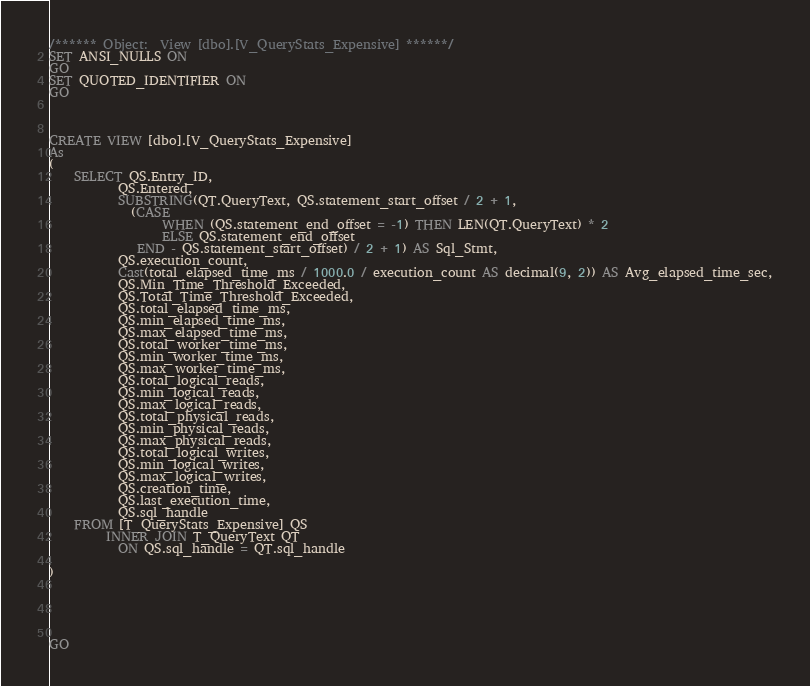Convert code to text. <code><loc_0><loc_0><loc_500><loc_500><_SQL_>/****** Object:  View [dbo].[V_QueryStats_Expensive] ******/
SET ANSI_NULLS ON
GO
SET QUOTED_IDENTIFIER ON
GO



CREATE VIEW [dbo].[V_QueryStats_Expensive] 
As 
(
	SELECT QS.Entry_ID,
           QS.Entered,
	       SUBSTRING(QT.QueryText, QS.statement_start_offset / 2 + 1, 
	         (CASE
	              WHEN (QS.statement_end_offset = -1) THEN LEN(QT.QueryText) * 2
	              ELSE QS.statement_end_offset
	          END - QS.statement_start_offset) / 2 + 1) AS Sql_Stmt,
	       QS.execution_count,
	       Cast(total_elapsed_time_ms / 1000.0 / execution_count AS decimal(9, 2)) AS Avg_elapsed_time_sec,
	       QS.Min_Time_Threshold_Exceeded,
	       QS.Total_Time_Threshold_Exceeded,
	       QS.total_elapsed_time_ms,
	       QS.min_elapsed_time_ms,
	       QS.max_elapsed_time_ms,
	       QS.total_worker_time_ms,
	       QS.min_worker_time_ms,
	       QS.max_worker_time_ms,
	       QS.total_logical_reads,
	       QS.min_logical_reads,
	       QS.max_logical_reads,
	       QS.total_physical_reads,
	       QS.min_physical_reads,
	       QS.max_physical_reads,
	       QS.total_logical_writes,
	       QS.min_logical_writes,
	       QS.max_logical_writes,
	       QS.creation_time,
	       QS.last_execution_time,
	       QS.sql_handle
	FROM [T_QueryStats_Expensive] QS
	     INNER JOIN T_QueryText QT
	       ON QS.sql_handle = QT.sql_handle

)





GO
</code> 